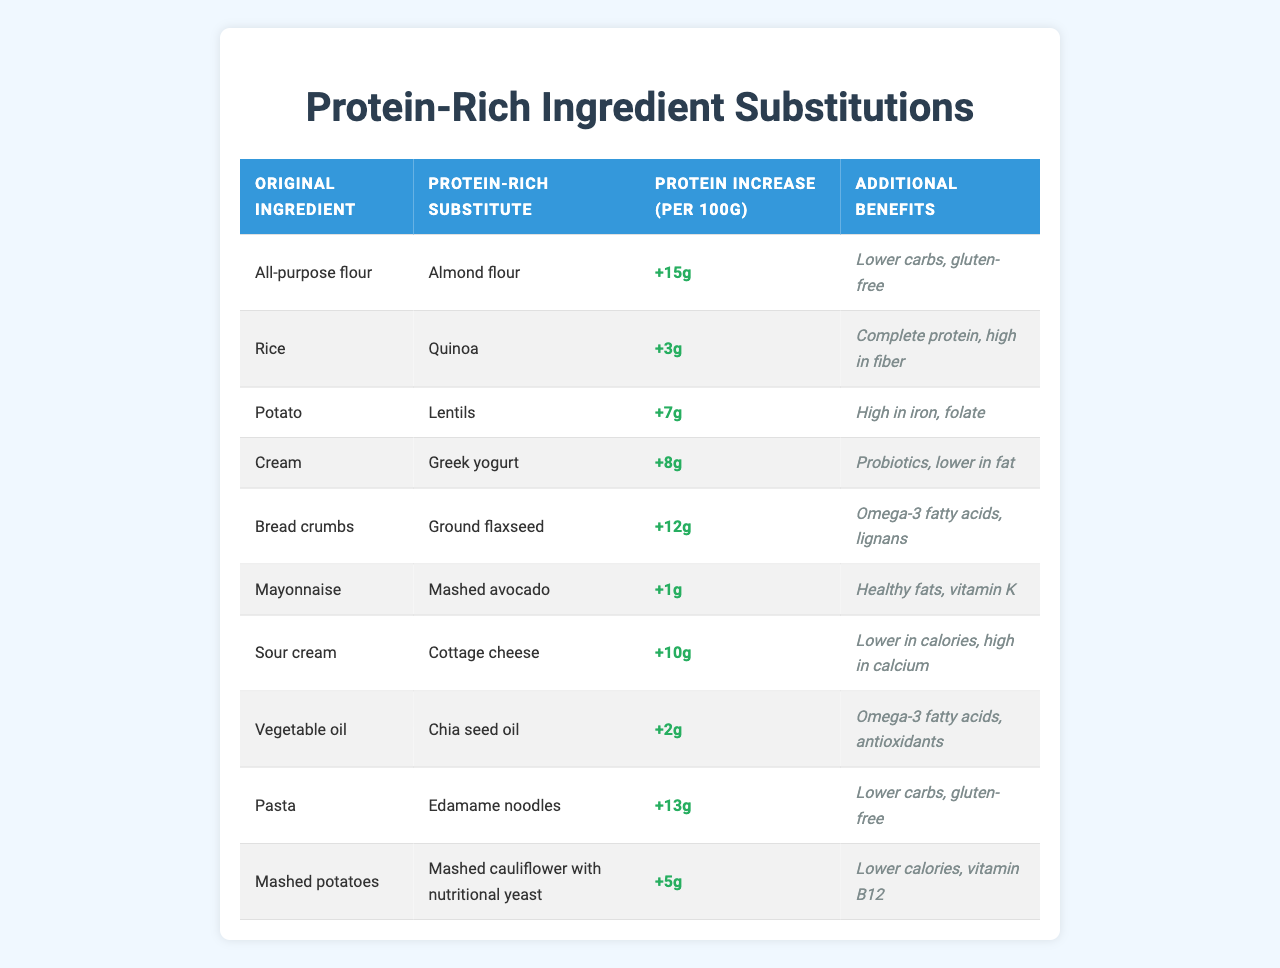What is the protein increase when substituting all-purpose flour with almond flour? The table shows that substituting all-purpose flour with almond flour results in a protein increase of 15 grams per 100 grams.
Answer: 15g Which substitute provides the highest protein increase? By reviewing the protein increases listed, almond flour offers the highest increase at 15 grams per 100 grams.
Answer: Almond flour Does quinoa offer more protein than rice when substituted? The table indicates a protein increase of 3 grams per 100 grams with quinoa, while rice does not provide a protein increase. Thus, quinoa indeed offers more protein.
Answer: Yes What are the additional benefits of using Greek yogurt instead of cream? The benefits listed for Greek yogurt are probiotics and being lower in fat, providing health advantages over cream.
Answer: Probiotics and lower in fat If you replace bread crumbs with ground flaxseed, how much protein do you gain? Ground flaxseed provides an increase of 12 grams of protein per 100 grams when used in place of bread crumbs.
Answer: 12g Which ingredient has the lowest protein increase when substituted? The data shows that mashed avocado as a substitute for mayonnaise has the lowest protein increase at 1 gram per 100 grams.
Answer: 1g How much total protein increase would you get if you replaced both pasta with edamame noodles and potato with lentils? The total increase would be the sum of their increases: 13 grams (edamame noodles) + 7 grams (lentils) = 20 grams per 100 grams total.
Answer: 20g Is cottage cheese a better substitute than sour cream based on protein increase? Cottage cheese provides a protein increase of 10 grams per 100 grams, which is higher than sour cream's protein value, confirming it as a better substitute.
Answer: Yes How does the protein increase of edamame noodles compare to that of lentils? Edamame noodles increase protein by 13 grams per 100 grams, while lentils increase it by 7 grams, showing that edamame noodles provide more protein.
Answer: More protein What is the average protein increase among all substitutes in the table? To find the average, add all protein increases (15 + 3 + 7 + 8 + 12 + 1 + 10 + 2 + 13 + 5 = 76) and divide by the number of substitutes (10), resulting in an average of 7.6 grams.
Answer: 7.6g 